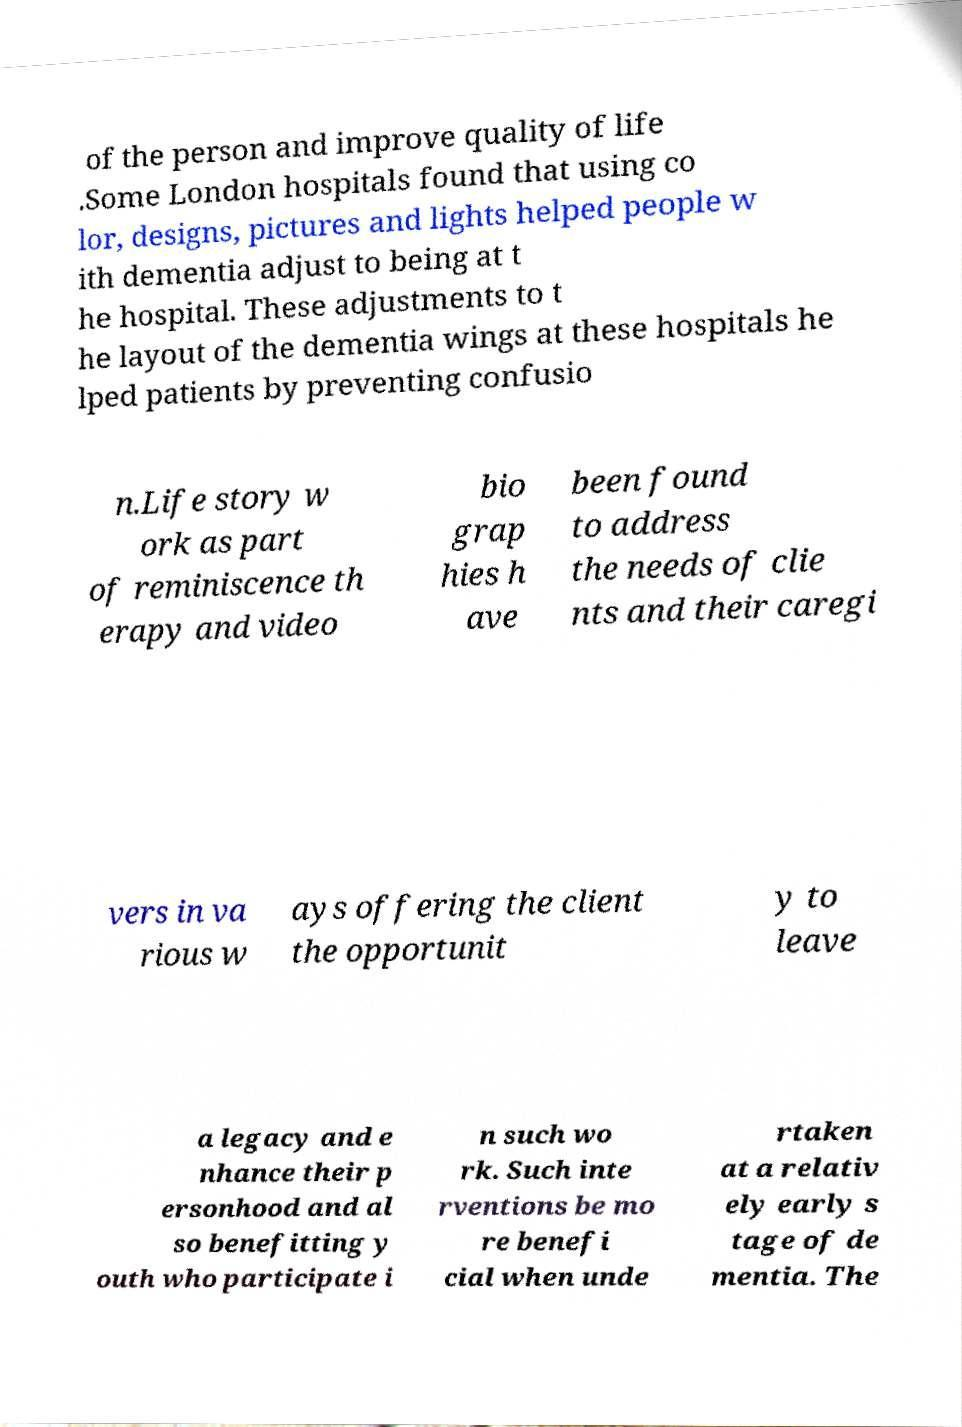Please identify and transcribe the text found in this image. of the person and improve quality of life .Some London hospitals found that using co lor, designs, pictures and lights helped people w ith dementia adjust to being at t he hospital. These adjustments to t he layout of the dementia wings at these hospitals he lped patients by preventing confusio n.Life story w ork as part of reminiscence th erapy and video bio grap hies h ave been found to address the needs of clie nts and their caregi vers in va rious w ays offering the client the opportunit y to leave a legacy and e nhance their p ersonhood and al so benefitting y outh who participate i n such wo rk. Such inte rventions be mo re benefi cial when unde rtaken at a relativ ely early s tage of de mentia. The 